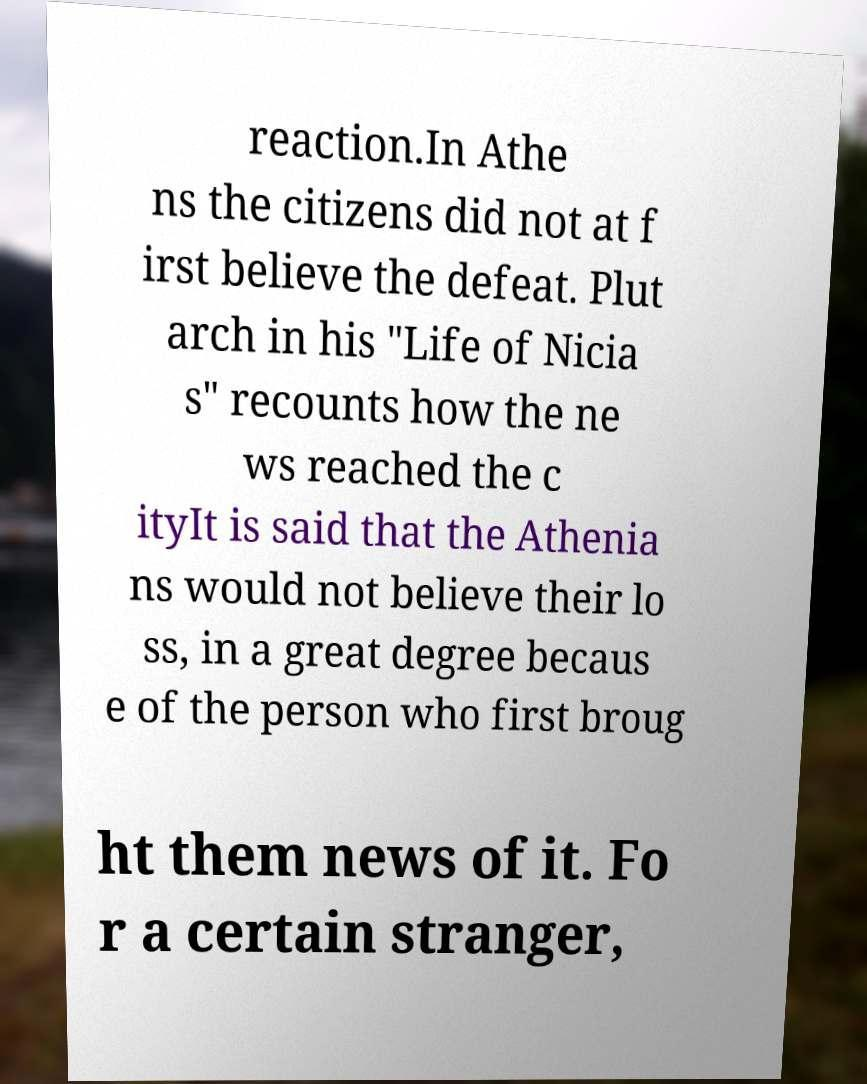Could you extract and type out the text from this image? reaction.In Athe ns the citizens did not at f irst believe the defeat. Plut arch in his "Life of Nicia s" recounts how the ne ws reached the c ityIt is said that the Athenia ns would not believe their lo ss, in a great degree becaus e of the person who first broug ht them news of it. Fo r a certain stranger, 